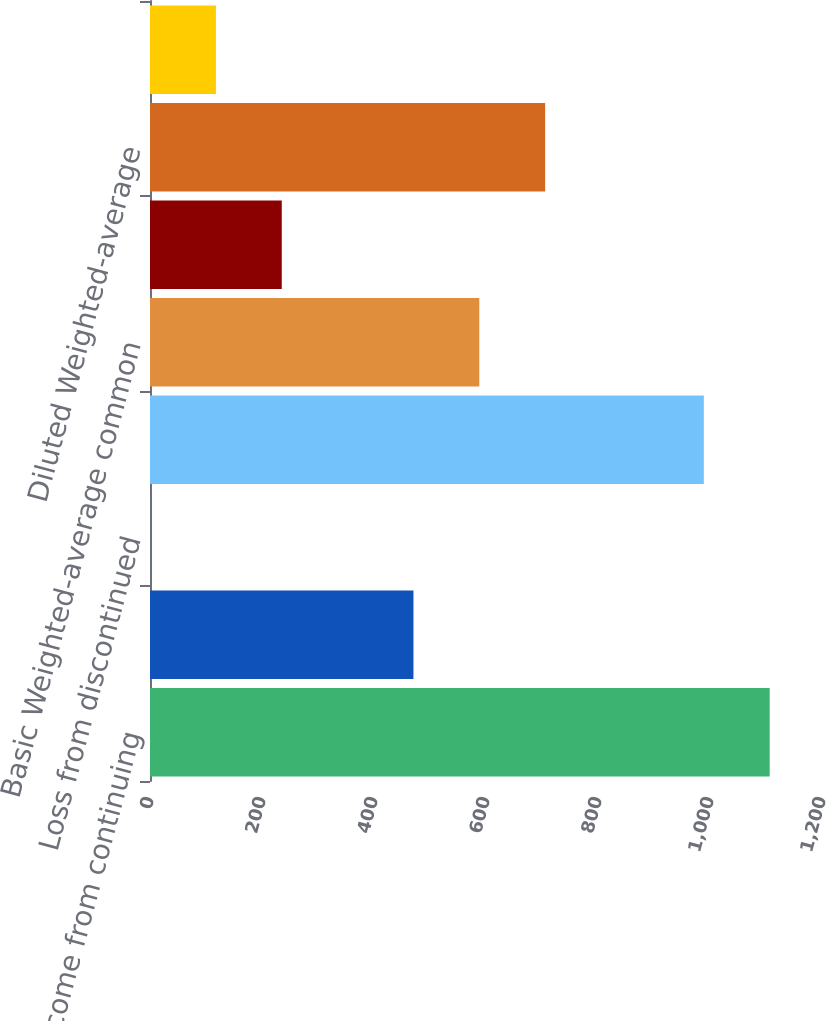Convert chart to OTSL. <chart><loc_0><loc_0><loc_500><loc_500><bar_chart><fcel>Income from continuing<fcel>Less Net income (loss)<fcel>Loss from discontinued<fcel>Net income attributable to<fcel>Basic Weighted-average common<fcel>Effect of potentially dilutive<fcel>Diluted Weighted-average<fcel>Net income<nl><fcel>1106.59<fcel>470.46<fcel>0.1<fcel>989<fcel>588.05<fcel>235.28<fcel>705.64<fcel>117.69<nl></chart> 